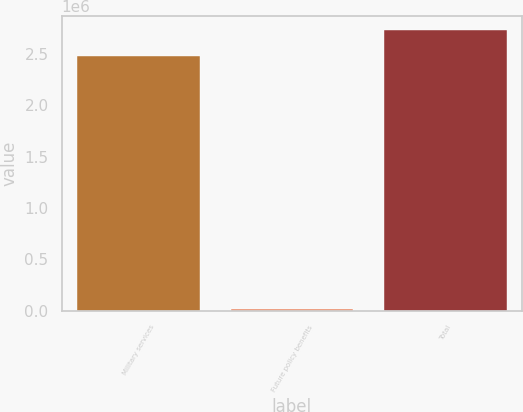Convert chart to OTSL. <chart><loc_0><loc_0><loc_500><loc_500><bar_chart><fcel>Military services<fcel>Future policy benefits<fcel>Total<nl><fcel>2.48181e+06<fcel>16392<fcel>2.73e+06<nl></chart> 